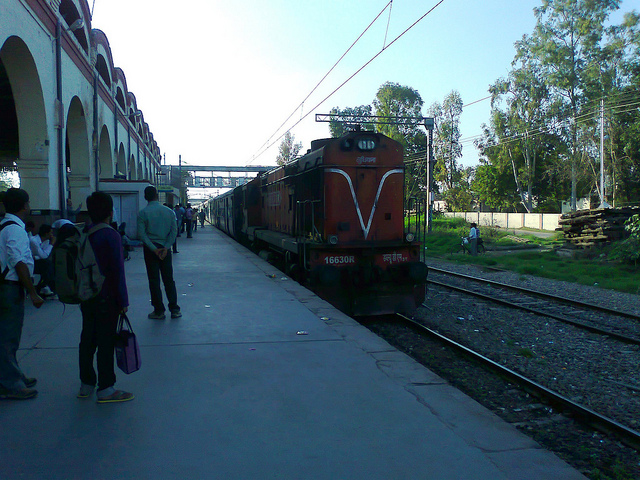<image>Where is the train heading? It is unknown where the train is heading. What city is this train station located in? It is unknown which city this train station is located in. The guesses range from Los Angeles, London, Paris, to somewhere in Asia, India, or China. Where is the train heading? I am not sure where the train is heading. It can be heading towards the station, east, north or forward. What city is this train station located in? It is unknown what city this train station is located in. Some guesses are Los Angeles, London, Paris, Peking, India or China. 